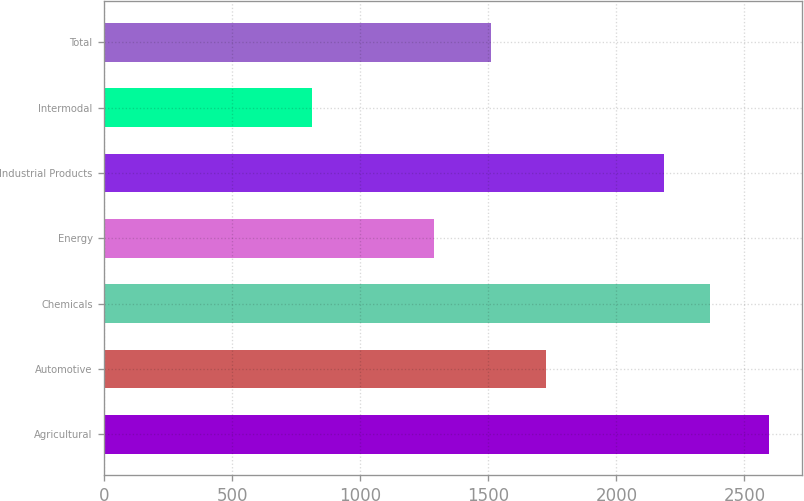Convert chart to OTSL. <chart><loc_0><loc_0><loc_500><loc_500><bar_chart><fcel>Agricultural<fcel>Automotive<fcel>Chemicals<fcel>Energy<fcel>Industrial Products<fcel>Intermodal<fcel>Total<nl><fcel>2595<fcel>1724<fcel>2365.2<fcel>1286<fcel>2187<fcel>813<fcel>1509<nl></chart> 